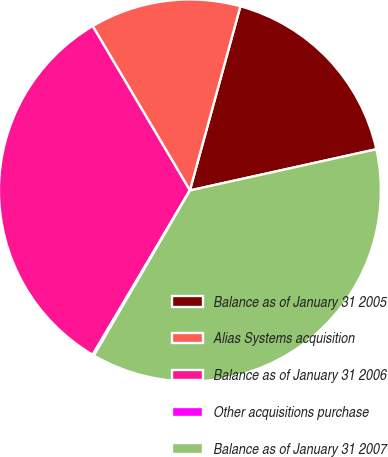Convert chart. <chart><loc_0><loc_0><loc_500><loc_500><pie_chart><fcel>Balance as of January 31 2005<fcel>Alias Systems acquisition<fcel>Balance as of January 31 2006<fcel>Other acquisitions purchase<fcel>Balance as of January 31 2007<nl><fcel>17.28%<fcel>12.76%<fcel>33.0%<fcel>0.12%<fcel>36.85%<nl></chart> 